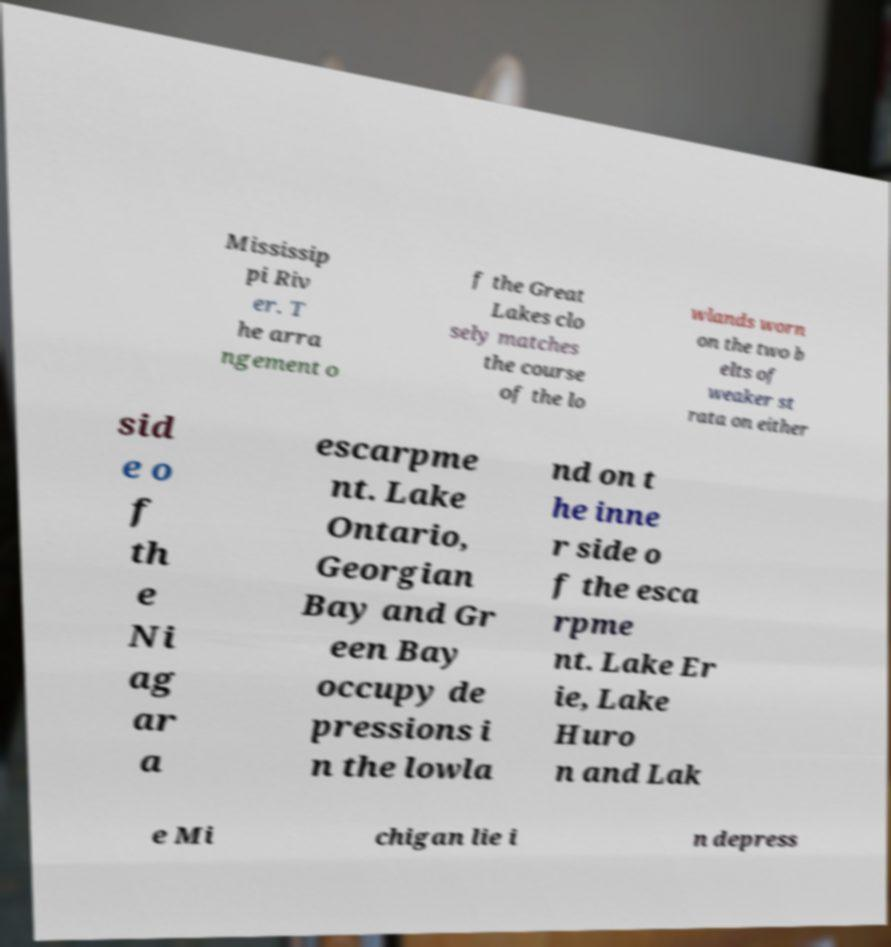Please read and relay the text visible in this image. What does it say? Mississip pi Riv er. T he arra ngement o f the Great Lakes clo sely matches the course of the lo wlands worn on the two b elts of weaker st rata on either sid e o f th e Ni ag ar a escarpme nt. Lake Ontario, Georgian Bay and Gr een Bay occupy de pressions i n the lowla nd on t he inne r side o f the esca rpme nt. Lake Er ie, Lake Huro n and Lak e Mi chigan lie i n depress 